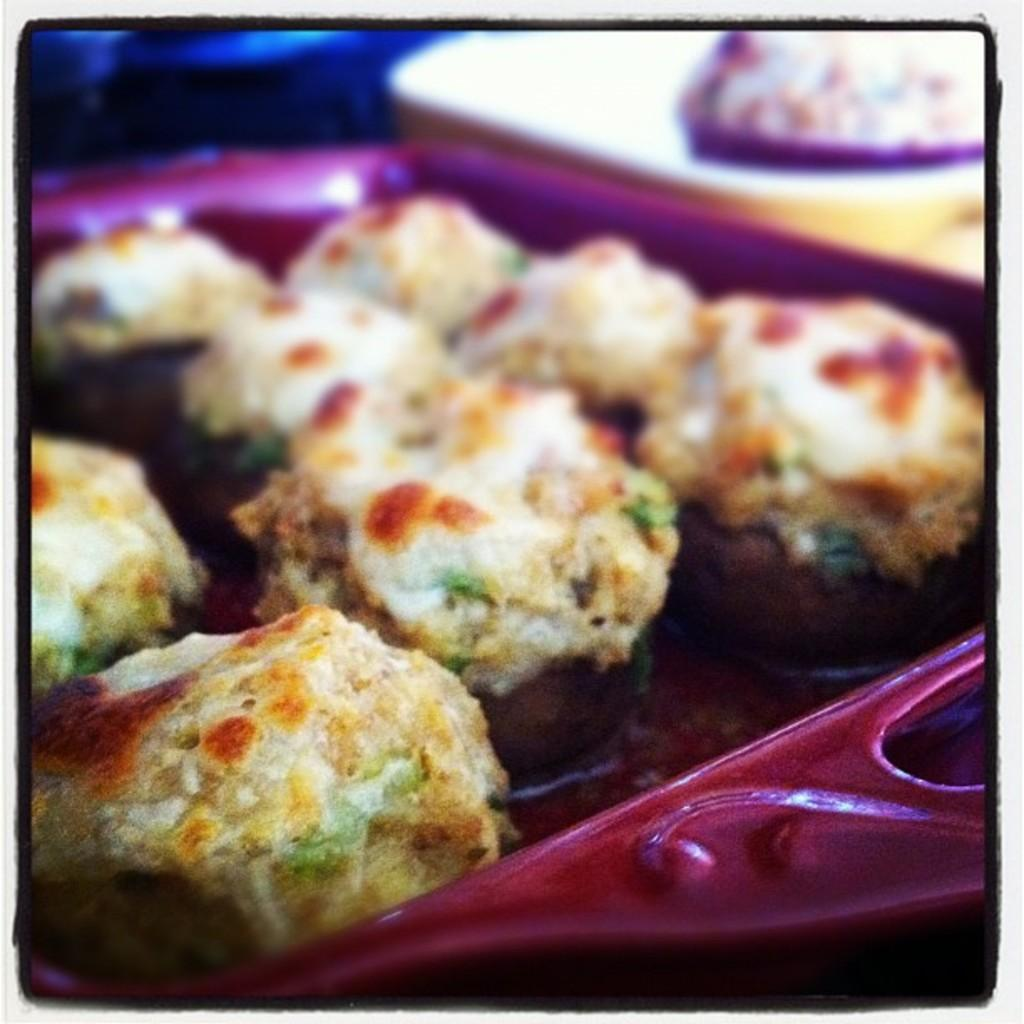What is present on the plate in the image? There are food items on a purple plate in the image. Can you describe the plate in the image? The plate in the image is purple. Is there any issue with the clarity of the image? Yes, the part of the image with the plate is slightly blurred. What type of flame can be seen coming from the food items in the image? There is no flame present in the image; it only shows food items on a purple plate. 